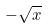<formula> <loc_0><loc_0><loc_500><loc_500>- \sqrt { x }</formula> 